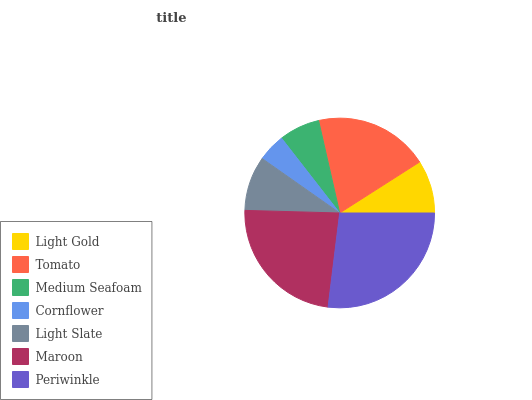Is Cornflower the minimum?
Answer yes or no. Yes. Is Periwinkle the maximum?
Answer yes or no. Yes. Is Tomato the minimum?
Answer yes or no. No. Is Tomato the maximum?
Answer yes or no. No. Is Tomato greater than Light Gold?
Answer yes or no. Yes. Is Light Gold less than Tomato?
Answer yes or no. Yes. Is Light Gold greater than Tomato?
Answer yes or no. No. Is Tomato less than Light Gold?
Answer yes or no. No. Is Light Slate the high median?
Answer yes or no. Yes. Is Light Slate the low median?
Answer yes or no. Yes. Is Periwinkle the high median?
Answer yes or no. No. Is Cornflower the low median?
Answer yes or no. No. 